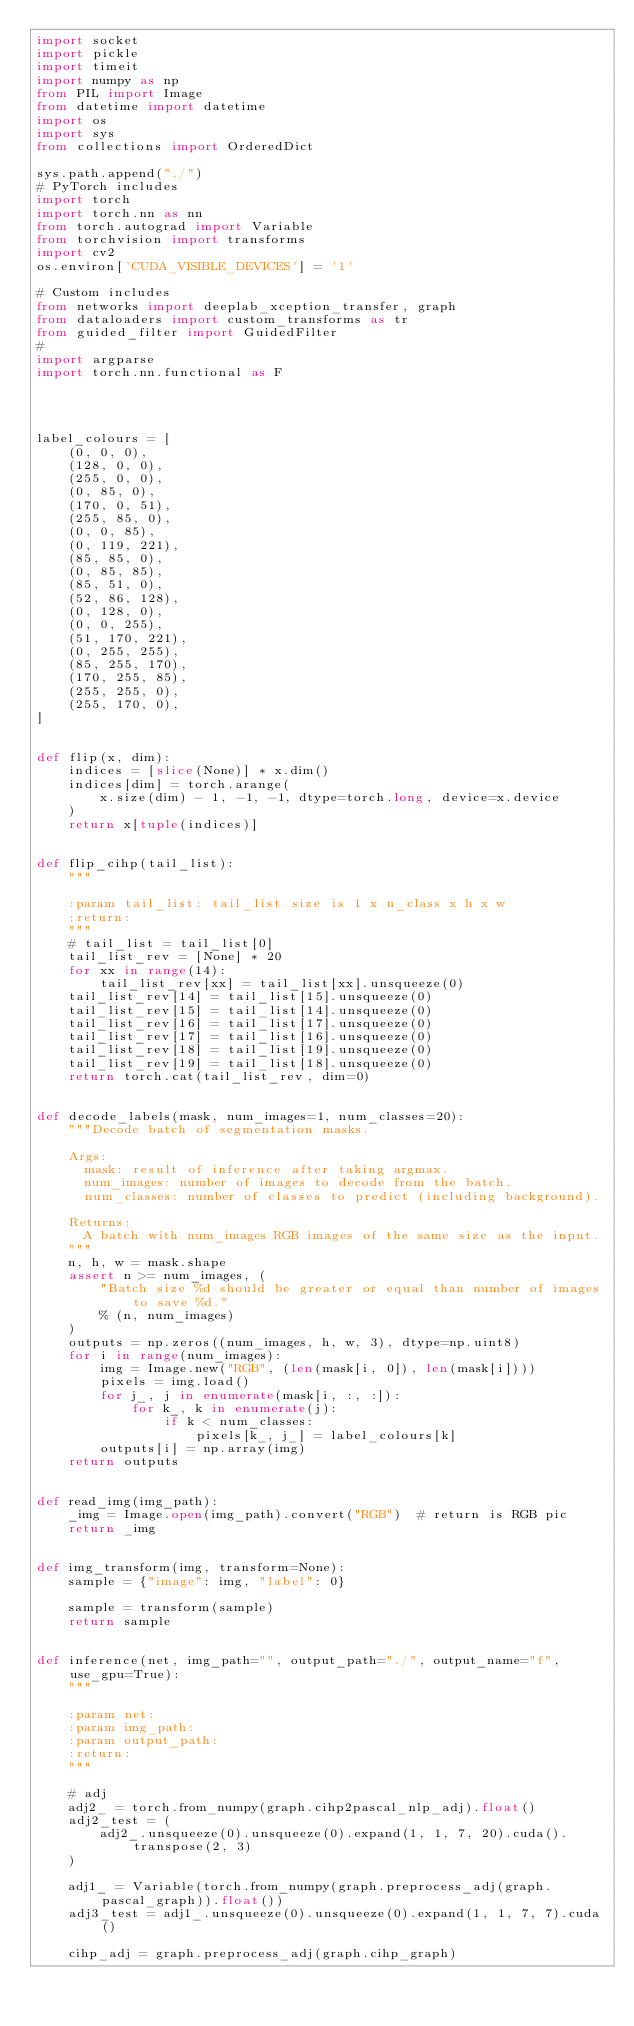Convert code to text. <code><loc_0><loc_0><loc_500><loc_500><_Python_>import socket
import pickle
import timeit
import numpy as np
from PIL import Image
from datetime import datetime
import os
import sys
from collections import OrderedDict

sys.path.append("./")
# PyTorch includes
import torch
import torch.nn as nn
from torch.autograd import Variable
from torchvision import transforms
import cv2
os.environ['CUDA_VISIBLE_DEVICES'] = '1'

# Custom includes
from networks import deeplab_xception_transfer, graph
from dataloaders import custom_transforms as tr
from guided_filter import GuidedFilter
#
import argparse
import torch.nn.functional as F




label_colours = [
    (0, 0, 0),
    (128, 0, 0),
    (255, 0, 0),
    (0, 85, 0),
    (170, 0, 51),
    (255, 85, 0),
    (0, 0, 85),
    (0, 119, 221),
    (85, 85, 0),
    (0, 85, 85),
    (85, 51, 0),
    (52, 86, 128),
    (0, 128, 0),
    (0, 0, 255),
    (51, 170, 221),
    (0, 255, 255),
    (85, 255, 170),
    (170, 255, 85),
    (255, 255, 0),
    (255, 170, 0),
]


def flip(x, dim):
    indices = [slice(None)] * x.dim()
    indices[dim] = torch.arange(
        x.size(dim) - 1, -1, -1, dtype=torch.long, device=x.device
    )
    return x[tuple(indices)]


def flip_cihp(tail_list):
    """

    :param tail_list: tail_list size is 1 x n_class x h x w
    :return:
    """
    # tail_list = tail_list[0]
    tail_list_rev = [None] * 20
    for xx in range(14):
        tail_list_rev[xx] = tail_list[xx].unsqueeze(0)
    tail_list_rev[14] = tail_list[15].unsqueeze(0)
    tail_list_rev[15] = tail_list[14].unsqueeze(0)
    tail_list_rev[16] = tail_list[17].unsqueeze(0)
    tail_list_rev[17] = tail_list[16].unsqueeze(0)
    tail_list_rev[18] = tail_list[19].unsqueeze(0)
    tail_list_rev[19] = tail_list[18].unsqueeze(0)
    return torch.cat(tail_list_rev, dim=0)


def decode_labels(mask, num_images=1, num_classes=20):
    """Decode batch of segmentation masks.

    Args:
      mask: result of inference after taking argmax.
      num_images: number of images to decode from the batch.
      num_classes: number of classes to predict (including background).

    Returns:
      A batch with num_images RGB images of the same size as the input.
    """
    n, h, w = mask.shape
    assert n >= num_images, (
        "Batch size %d should be greater or equal than number of images to save %d."
        % (n, num_images)
    )
    outputs = np.zeros((num_images, h, w, 3), dtype=np.uint8)
    for i in range(num_images):
        img = Image.new("RGB", (len(mask[i, 0]), len(mask[i])))
        pixels = img.load()
        for j_, j in enumerate(mask[i, :, :]):
            for k_, k in enumerate(j):
                if k < num_classes:
                    pixels[k_, j_] = label_colours[k]
        outputs[i] = np.array(img)
    return outputs


def read_img(img_path):
    _img = Image.open(img_path).convert("RGB")  # return is RGB pic
    return _img


def img_transform(img, transform=None):
    sample = {"image": img, "label": 0}

    sample = transform(sample)
    return sample


def inference(net, img_path="", output_path="./", output_name="f", use_gpu=True):
    """

    :param net:
    :param img_path:
    :param output_path:
    :return:
    """

    # adj
    adj2_ = torch.from_numpy(graph.cihp2pascal_nlp_adj).float()
    adj2_test = (
        adj2_.unsqueeze(0).unsqueeze(0).expand(1, 1, 7, 20).cuda().transpose(2, 3)
    )

    adj1_ = Variable(torch.from_numpy(graph.preprocess_adj(graph.pascal_graph)).float())
    adj3_test = adj1_.unsqueeze(0).unsqueeze(0).expand(1, 1, 7, 7).cuda()

    cihp_adj = graph.preprocess_adj(graph.cihp_graph)</code> 